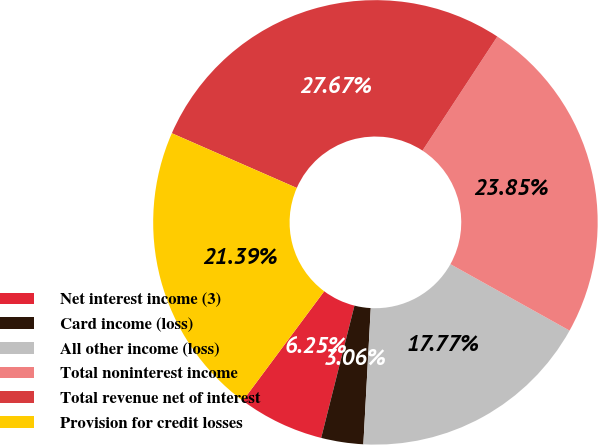Convert chart. <chart><loc_0><loc_0><loc_500><loc_500><pie_chart><fcel>Net interest income (3)<fcel>Card income (loss)<fcel>All other income (loss)<fcel>Total noninterest income<fcel>Total revenue net of interest<fcel>Provision for credit losses<nl><fcel>6.25%<fcel>3.06%<fcel>17.77%<fcel>23.85%<fcel>27.67%<fcel>21.39%<nl></chart> 